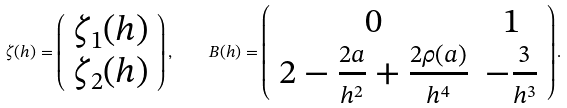Convert formula to latex. <formula><loc_0><loc_0><loc_500><loc_500>\zeta ( h ) = \left ( \begin{array} { l l } \zeta _ { 1 } ( h ) \\ \zeta _ { 2 } ( h ) \end{array} \right ) , \quad B ( h ) = \left ( \begin{array} { c c } 0 & 1 \\ 2 - \frac { 2 a } { h ^ { 2 } } + \frac { 2 \rho ( a ) } { h ^ { 4 } } & - \frac { 3 } { h ^ { 3 } } \end{array} \right ) .</formula> 